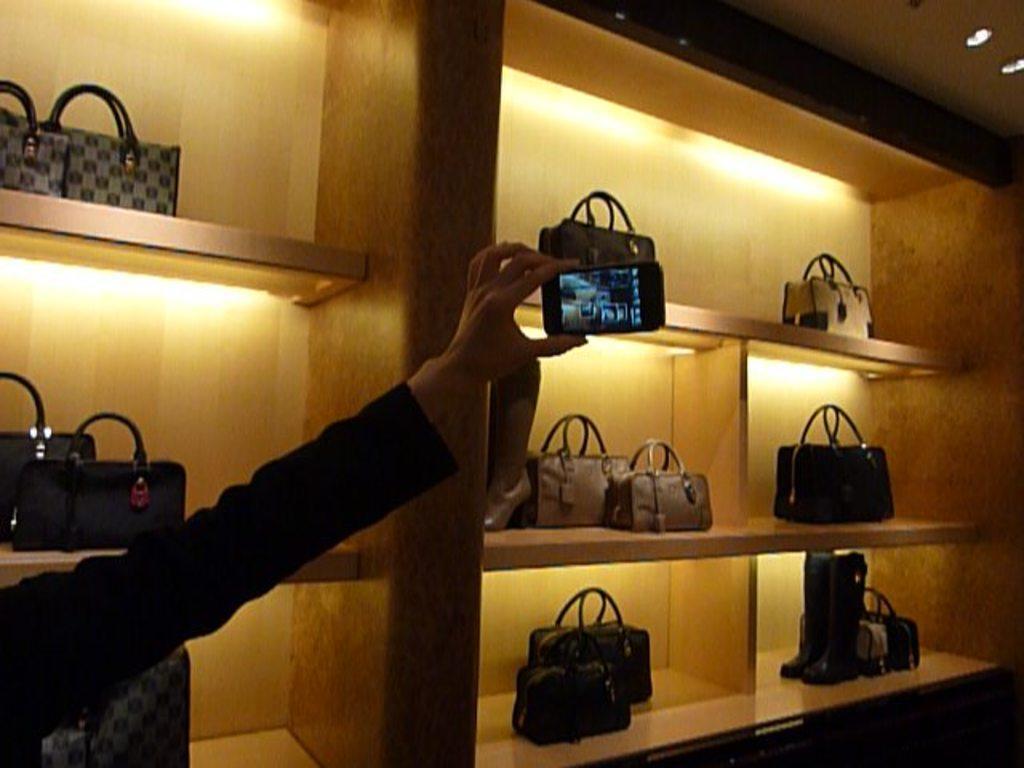Describe this image in one or two sentences. A person is holding a phone there are hand bags on the shelves and also lights 